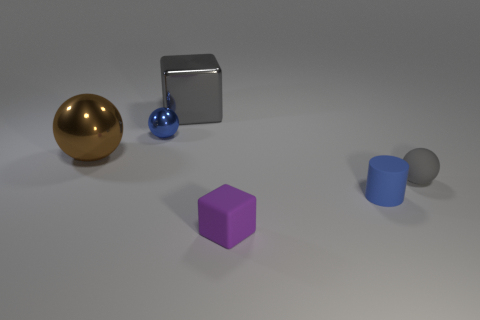There is a ball that is right of the small purple object; what number of small balls are behind it?
Your answer should be compact. 1. There is a tiny thing left of the object behind the tiny blue object that is behind the gray matte ball; what is its shape?
Keep it short and to the point. Sphere. There is a object that is the same color as the metal block; what is its size?
Offer a terse response. Small. What number of objects are big brown things or big red rubber cubes?
Your answer should be compact. 1. What is the color of the other shiny object that is the same size as the brown object?
Your answer should be very brief. Gray. There is a big gray metallic object; is its shape the same as the blue thing that is on the right side of the metallic block?
Offer a terse response. No. How many things are blue things left of the small cube or things behind the tiny purple block?
Your answer should be compact. 5. There is a tiny object that is the same color as the small cylinder; what shape is it?
Your response must be concise. Sphere. There is a gray object that is right of the tiny cylinder; what is its shape?
Offer a very short reply. Sphere. There is a gray object that is in front of the large gray object; is its shape the same as the small blue rubber object?
Provide a succinct answer. No. 